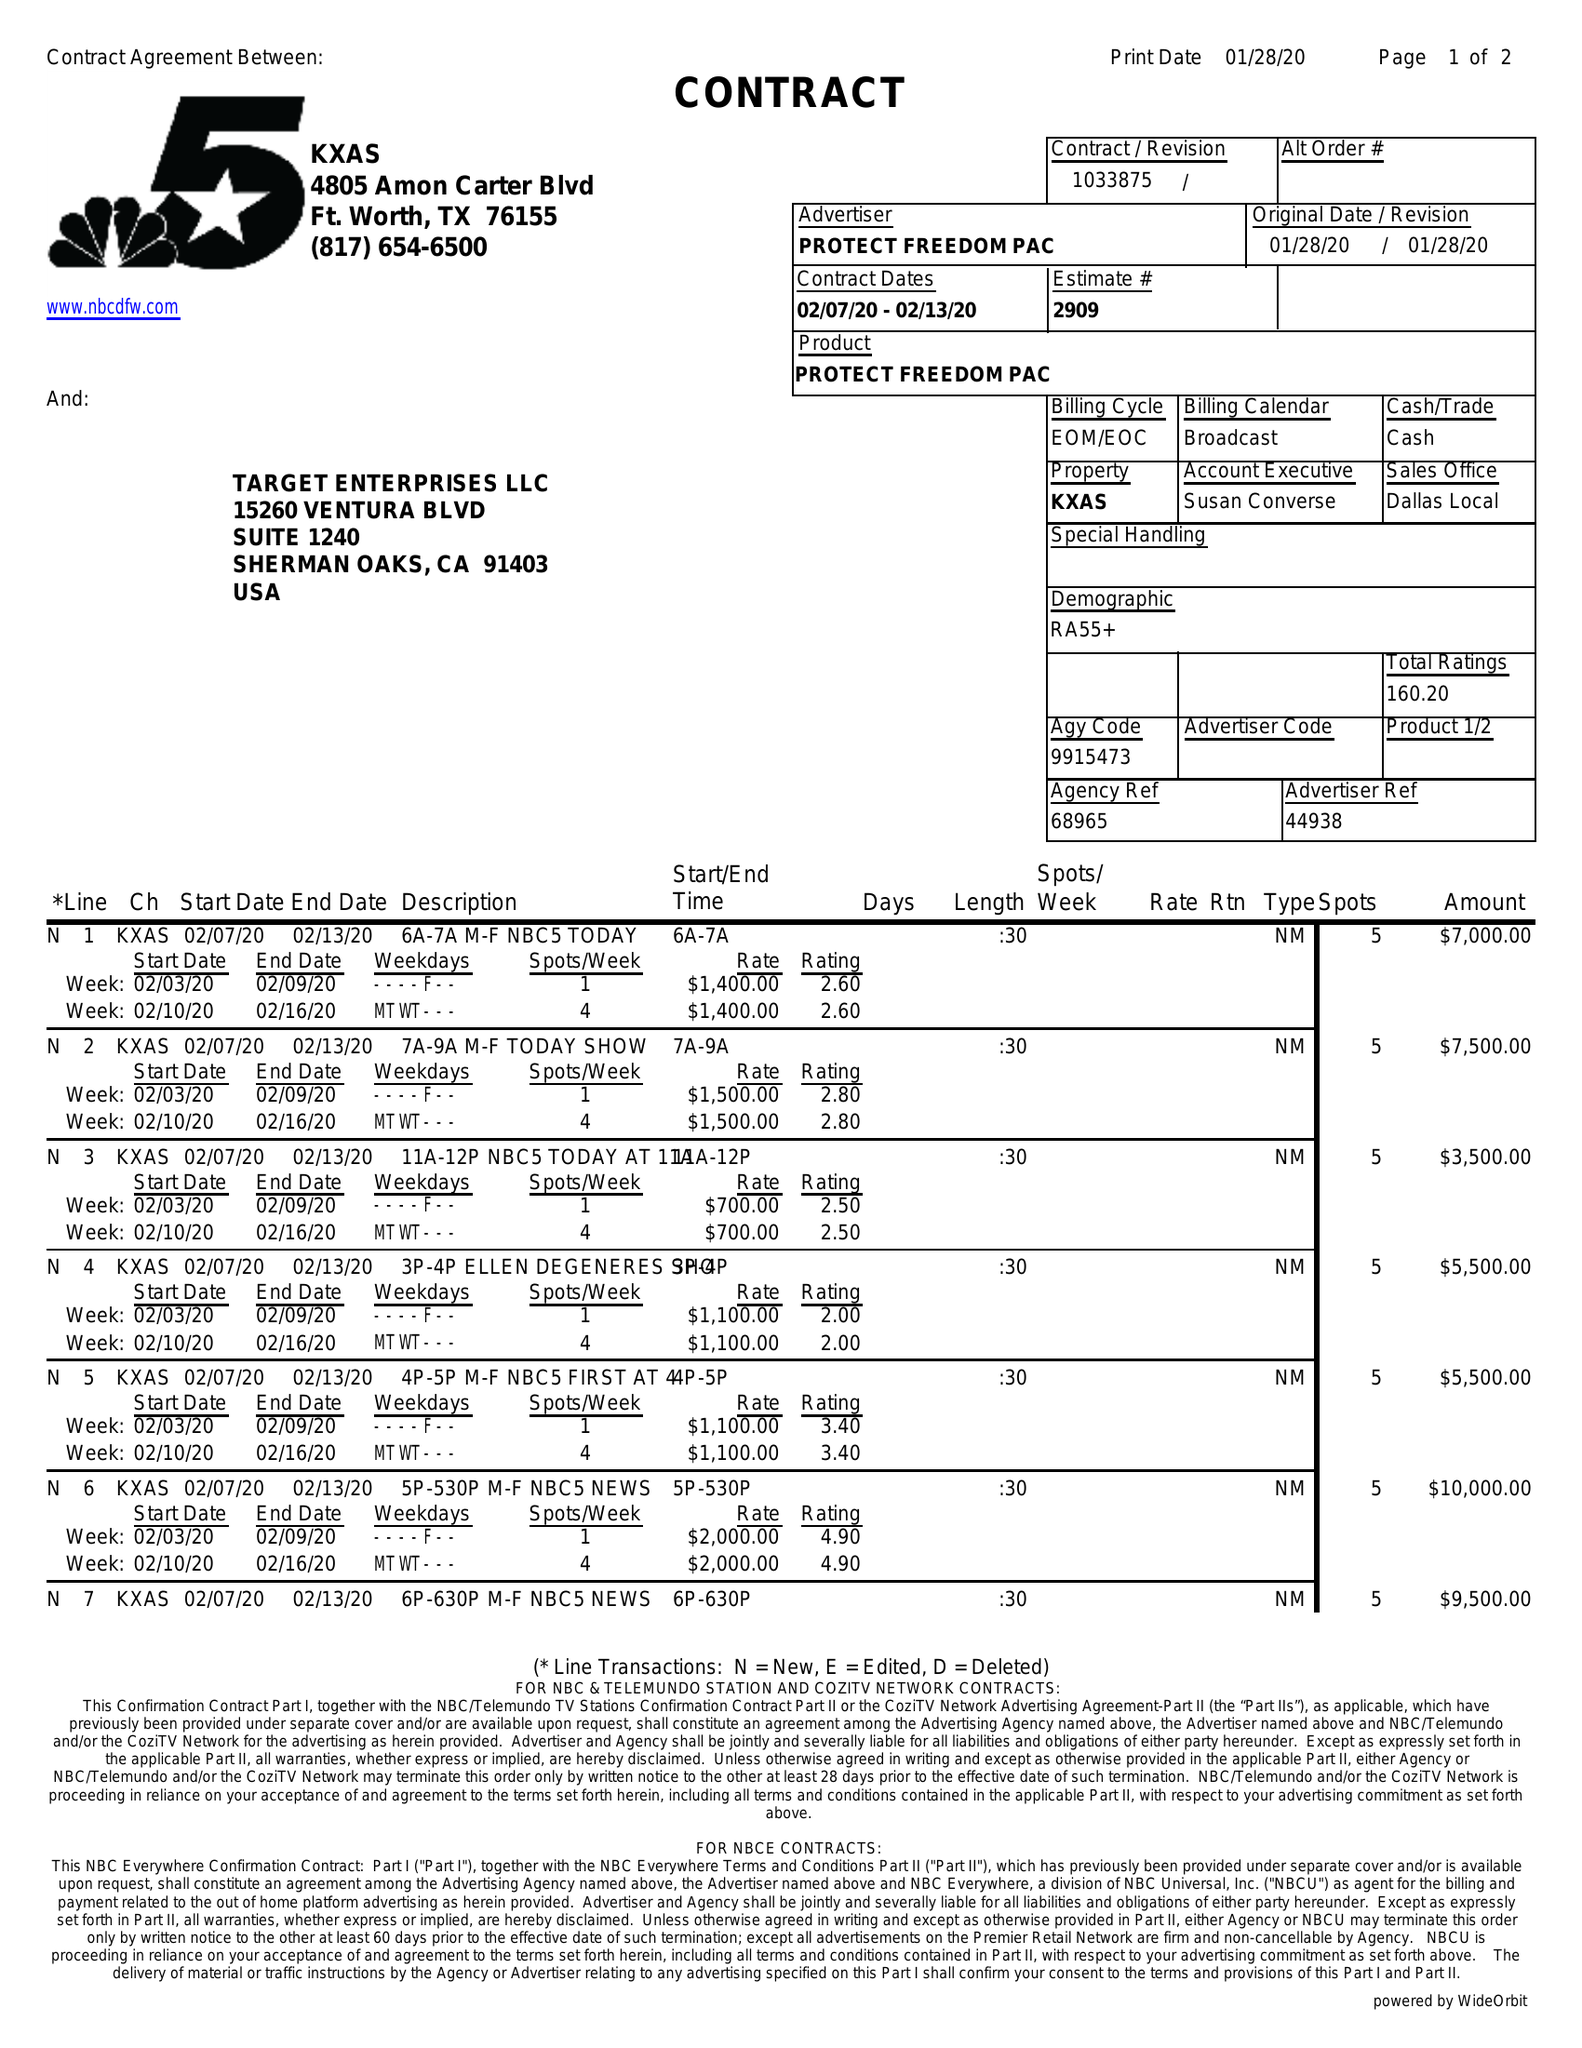What is the value for the advertiser?
Answer the question using a single word or phrase. PROTECT FREEDOM PAC 